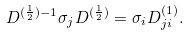Convert formula to latex. <formula><loc_0><loc_0><loc_500><loc_500>D ^ { ( \frac { 1 } { 2 } ) - 1 } { \sigma } _ { j } D ^ { ( \frac { 1 } { 2 } ) } = { \sigma } _ { i } D _ { j i } ^ { ( 1 ) } .</formula> 